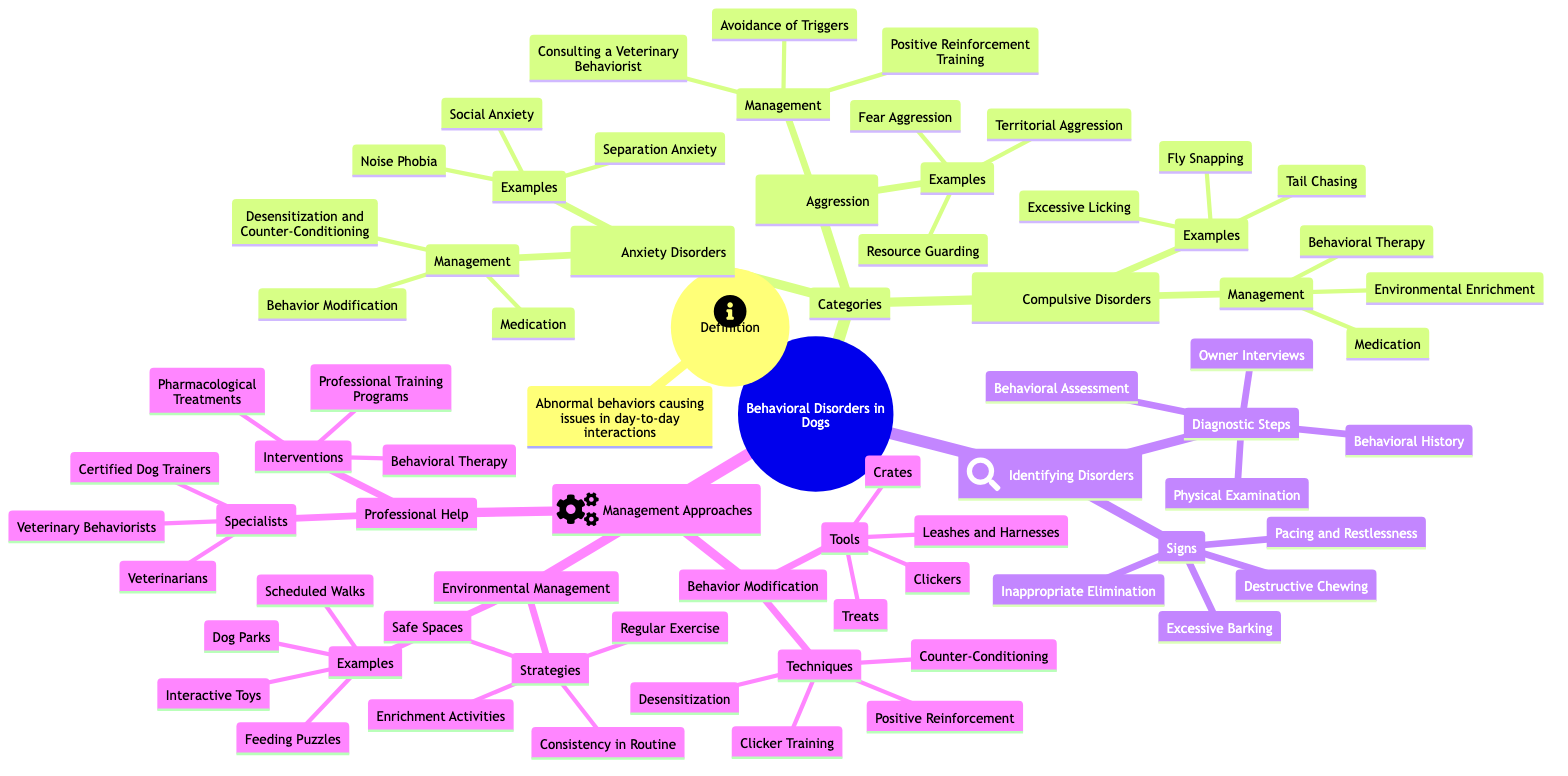What are the three categories of behavioral disorders? The diagram lists three categories under Behavioral Disorders: Anxiety Disorders, Aggression, and Compulsive Disorders.
Answer: Anxiety Disorders, Aggression, Compulsive Disorders What is a sign of identifying behavioral disorders in dogs? One of the signs indicated in the diagram for identifying behavioral disorders is Excessive Barking.
Answer: Excessive Barking How many examples are given for Anxiety Disorders? The diagram specifies that there are three examples listed under Anxiety Disorders: Separation Anxiety, Noise Phobia, and Social Anxiety.
Answer: Three What management approach involves positive reinforcement? The management approach that includes positive reinforcement is Behavior Modification, as indicated in the management section of the diagram.
Answer: Behavior Modification Which professional can help manage aggressive behaviors in dogs? According to the diagram, a Veterinary Behaviorist can help manage aggressive behaviors in dogs, as mentioned under the Professional Help section.
Answer: Veterinary Behaviorist What is one technique used in Behavior Modification? The diagram highlights several techniques, one of which is Clicker Training, found in the Behavior Modification section.
Answer: Clicker Training Which disorder includes Tail Chasing as an example? Tail Chasing is listed as an example under the Compulsive Disorders category in the diagram.
Answer: Compulsive Disorders What is one strategy for Environmental Management? The diagram indicates Regular Exercise as one of the strategies for Environmental Management.
Answer: Regular Exercise What type of interventions can Veterinary Behaviorists provide? The diagram states that Veterinary Behaviorists can provide interventions such as Behavioral Therapy.
Answer: Behavioral Therapy 